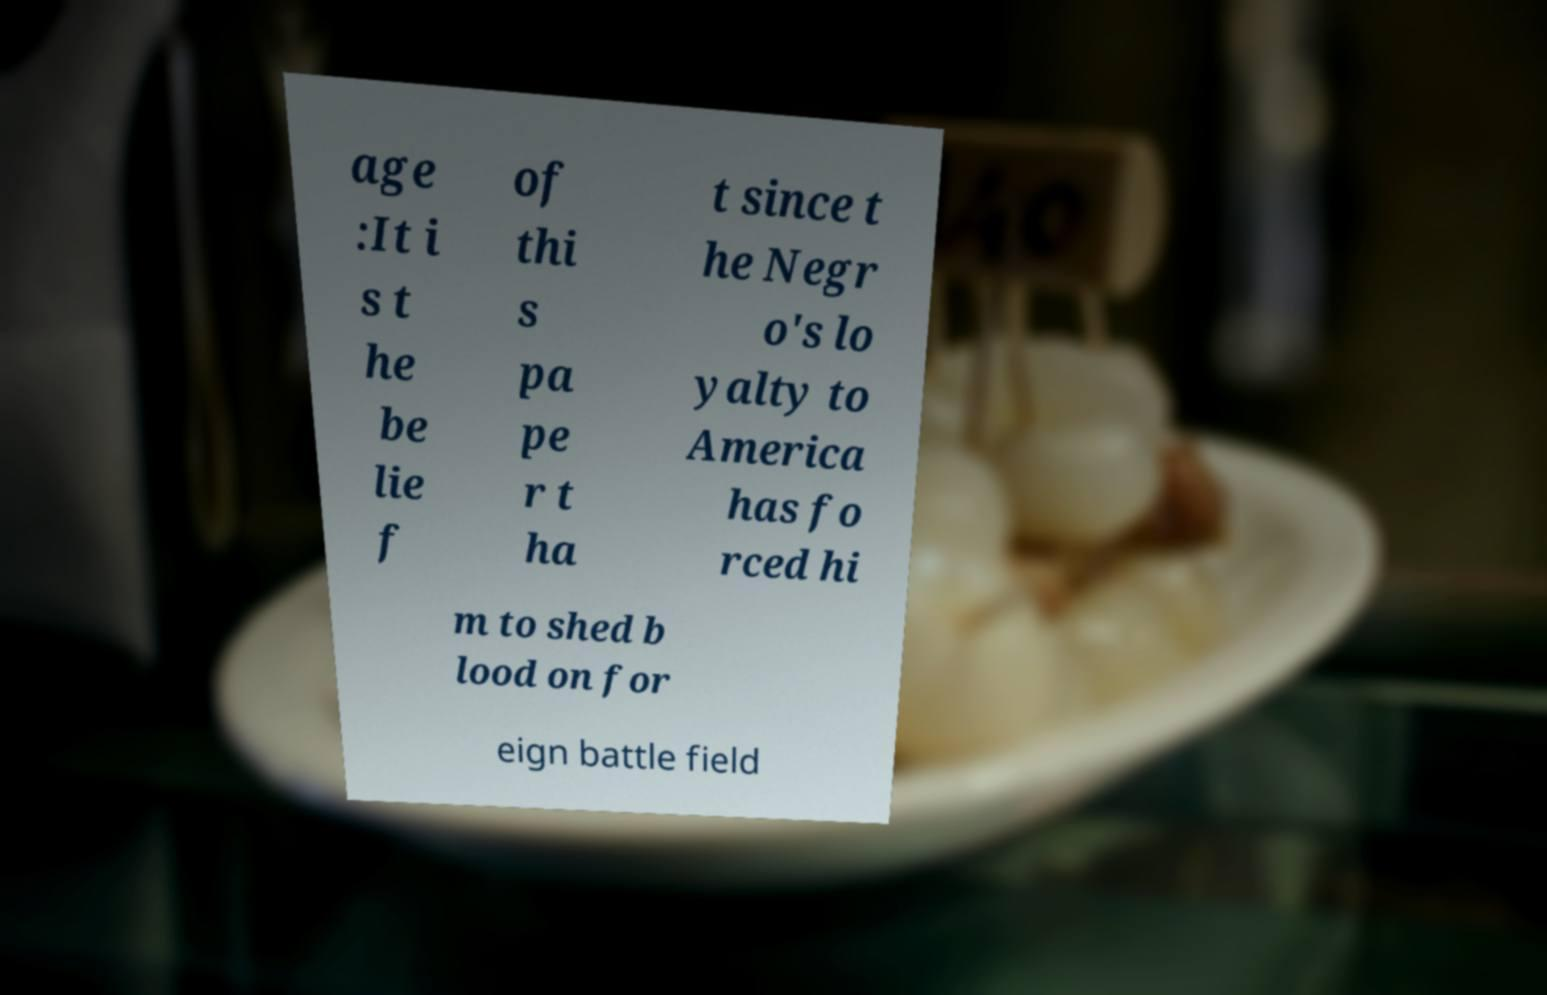For documentation purposes, I need the text within this image transcribed. Could you provide that? age :It i s t he be lie f of thi s pa pe r t ha t since t he Negr o's lo yalty to America has fo rced hi m to shed b lood on for eign battle field 